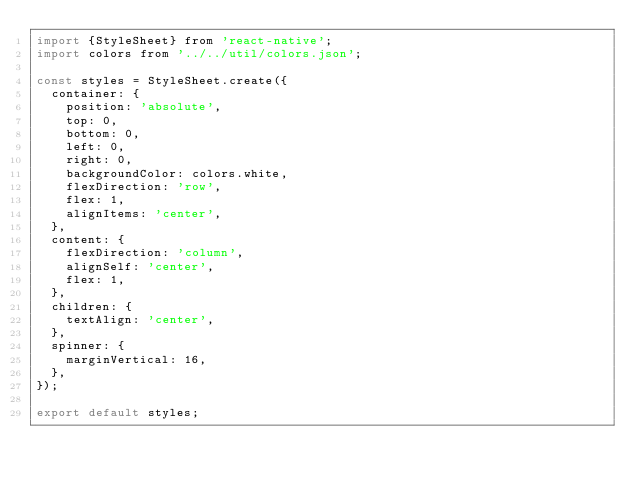Convert code to text. <code><loc_0><loc_0><loc_500><loc_500><_JavaScript_>import {StyleSheet} from 'react-native';
import colors from '../../util/colors.json';

const styles = StyleSheet.create({
  container: {
    position: 'absolute',
    top: 0,
    bottom: 0,
    left: 0,
    right: 0,
    backgroundColor: colors.white,
    flexDirection: 'row',
    flex: 1,
    alignItems: 'center',
  },
  content: {
    flexDirection: 'column',
    alignSelf: 'center',
    flex: 1,
  },
  children: {
    textAlign: 'center',
  },
  spinner: {
    marginVertical: 16,
  },
});

export default styles;
</code> 